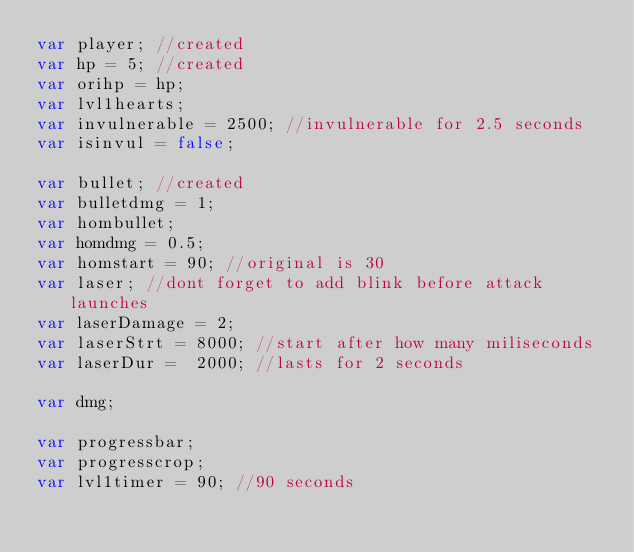<code> <loc_0><loc_0><loc_500><loc_500><_JavaScript_>var player; //created
var hp = 5;	//created
var orihp = hp;
var lvl1hearts;
var invulnerable = 2500; //invulnerable for 2.5 seconds
var isinvul = false;

var bullet; //created
var bulletdmg = 1;
var hombullet;
var homdmg = 0.5;
var homstart = 90; //original is 30
var laser; //dont forget to add blink before attack launches
var laserDamage = 2;
var laserStrt = 8000; //start after how many miliseconds
var laserDur =  2000; //lasts for 2 seconds

var dmg;

var progressbar; 
var progresscrop;
var lvl1timer = 90; //90 seconds</code> 